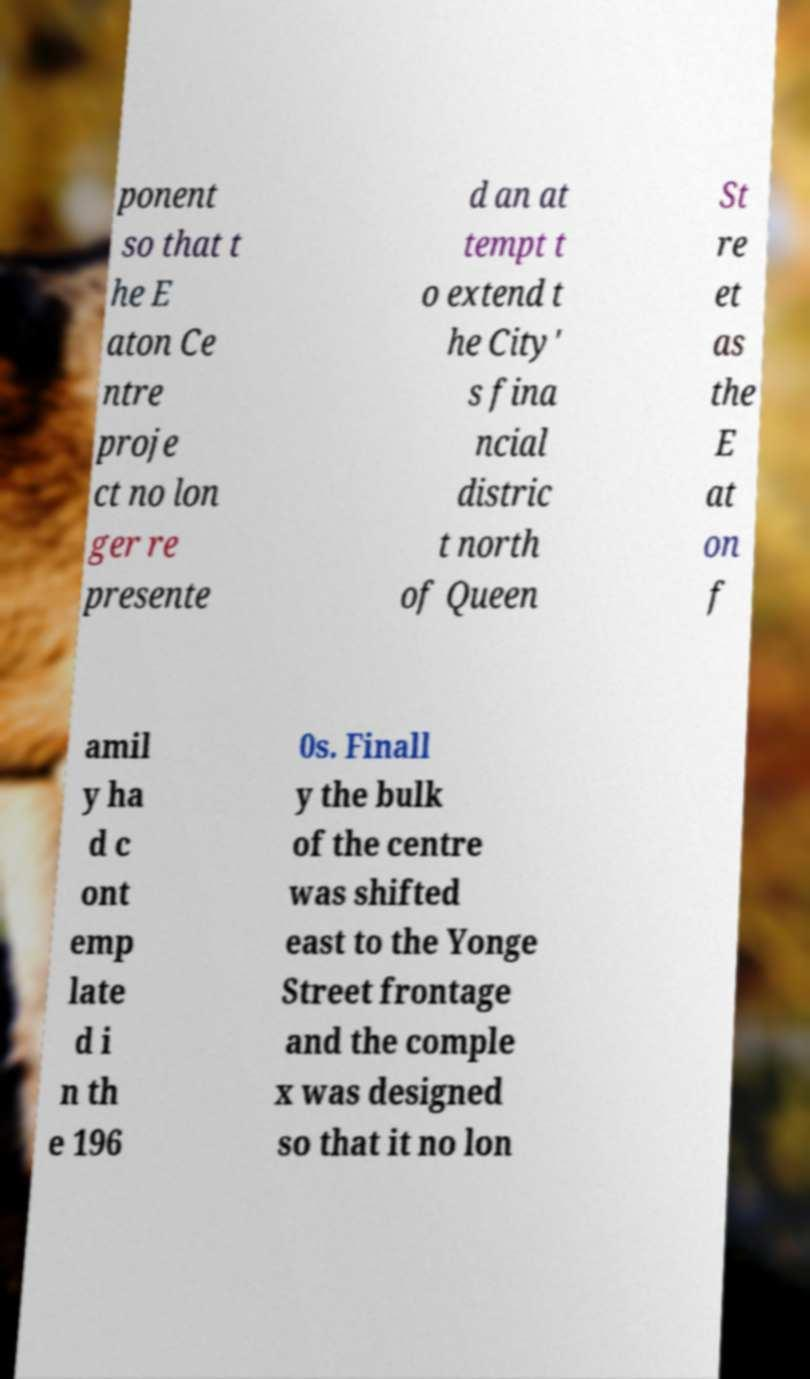Please read and relay the text visible in this image. What does it say? ponent so that t he E aton Ce ntre proje ct no lon ger re presente d an at tempt t o extend t he City' s fina ncial distric t north of Queen St re et as the E at on f amil y ha d c ont emp late d i n th e 196 0s. Finall y the bulk of the centre was shifted east to the Yonge Street frontage and the comple x was designed so that it no lon 